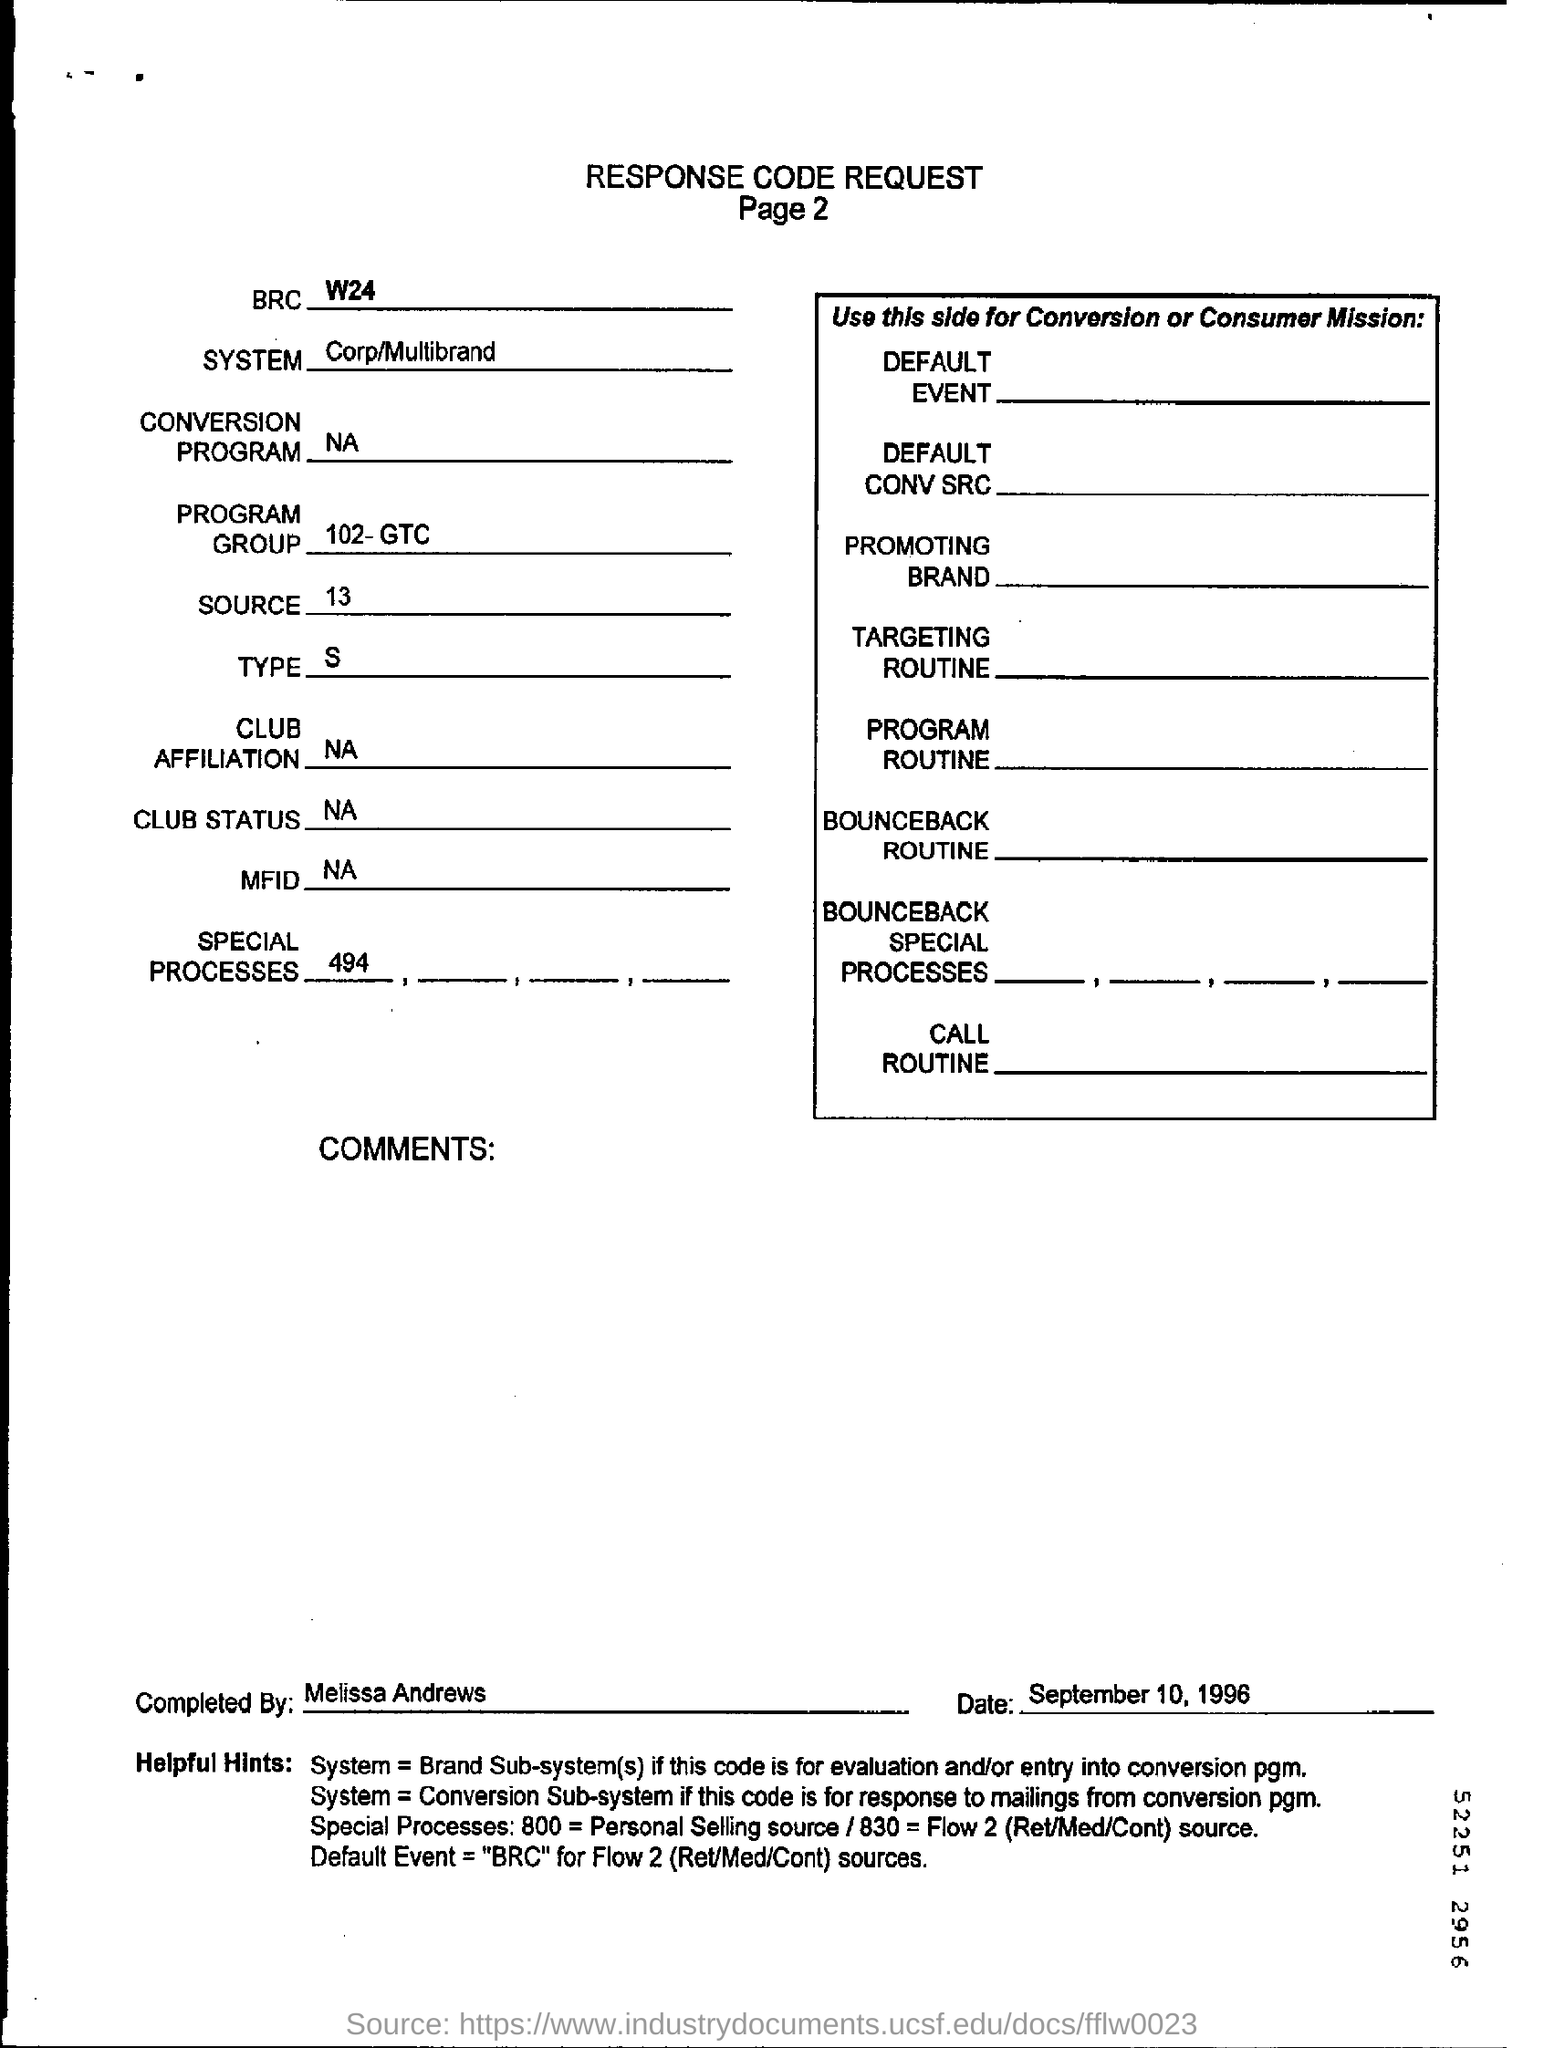Highlight a few significant elements in this photo. The individual who completed the response code request form is Melissa Andrews. The response code request form was dated September 10, 1996. 